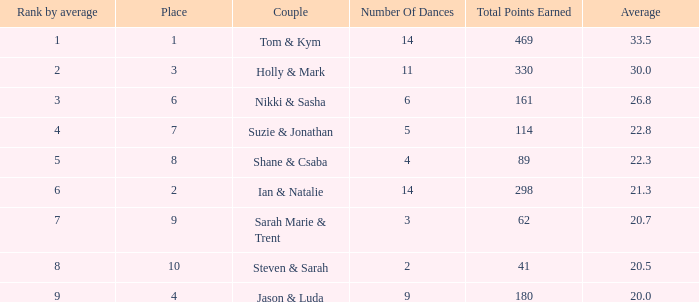What is the name of the couple if the total points earned is 161? Nikki & Sasha. 